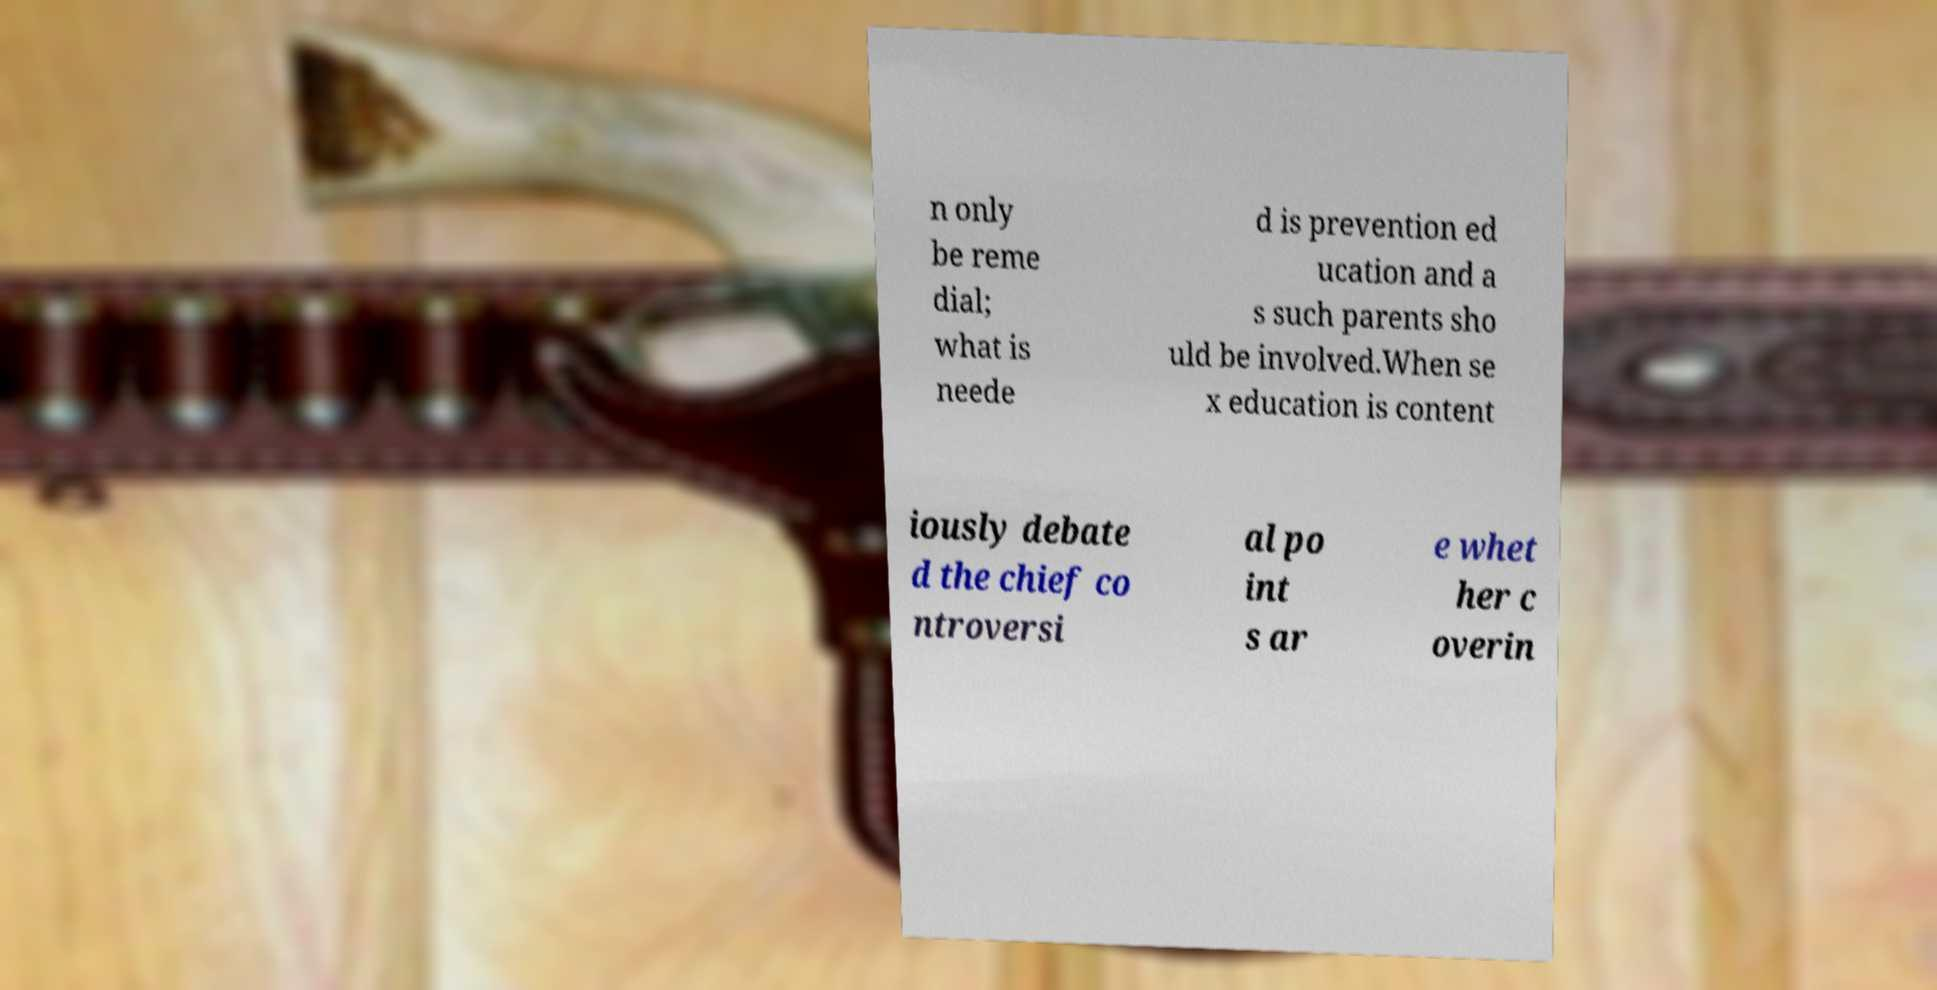Can you read and provide the text displayed in the image?This photo seems to have some interesting text. Can you extract and type it out for me? n only be reme dial; what is neede d is prevention ed ucation and a s such parents sho uld be involved.When se x education is content iously debate d the chief co ntroversi al po int s ar e whet her c overin 